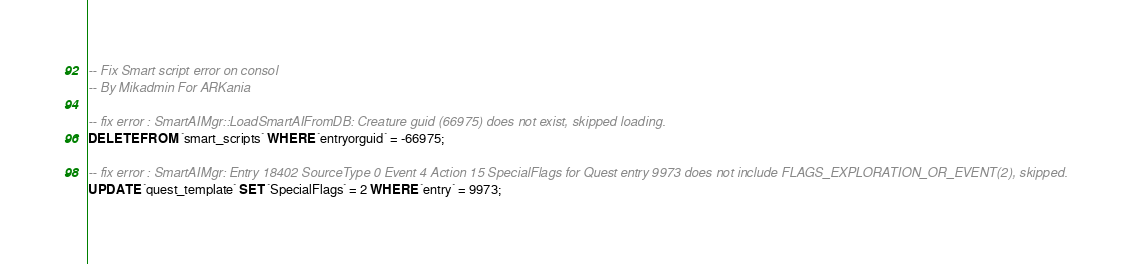Convert code to text. <code><loc_0><loc_0><loc_500><loc_500><_SQL_>-- Fix Smart script error on consol
-- By Mikadmin For ARKania

-- fix error : SmartAIMgr::LoadSmartAIFromDB: Creature guid (66975) does not exist, skipped loading.
DELETE FROM `smart_scripts` WHERE `entryorguid` = -66975;

-- fix error : SmartAIMgr: Entry 18402 SourceType 0 Event 4 Action 15 SpecialFlags for Quest entry 9973 does not include FLAGS_EXPLORATION_OR_EVENT(2), skipped.
UPDATE `quest_template` SET `SpecialFlags` = 2 WHERE `entry` = 9973;
</code> 